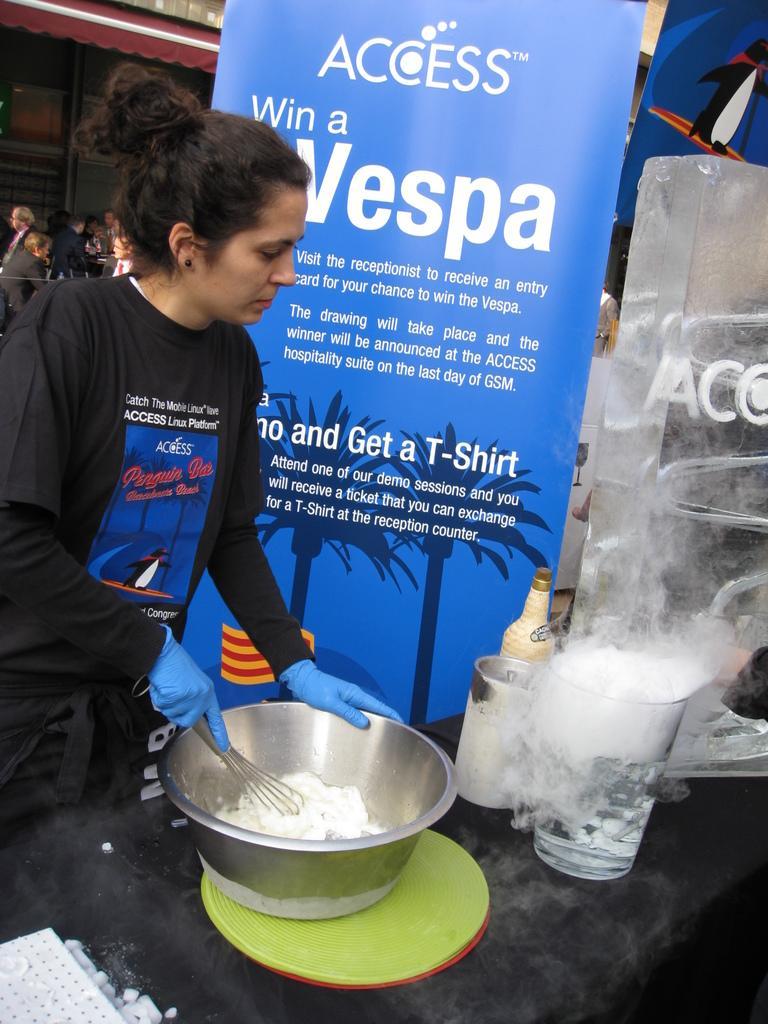Please provide a concise description of this image. On the left side, there is a woman in a t-shirt, wearing blue colored gloves, holding a bowl with a hand which is on a green colored object. This object is placed on a table on which there are some objects. In the background, there are banners, persons and a tent. 